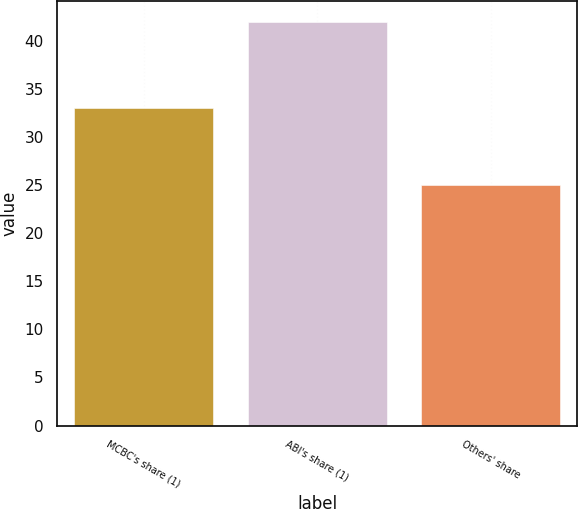<chart> <loc_0><loc_0><loc_500><loc_500><bar_chart><fcel>MCBC's share (1)<fcel>ABI's share (1)<fcel>Others' share<nl><fcel>33<fcel>42<fcel>25<nl></chart> 